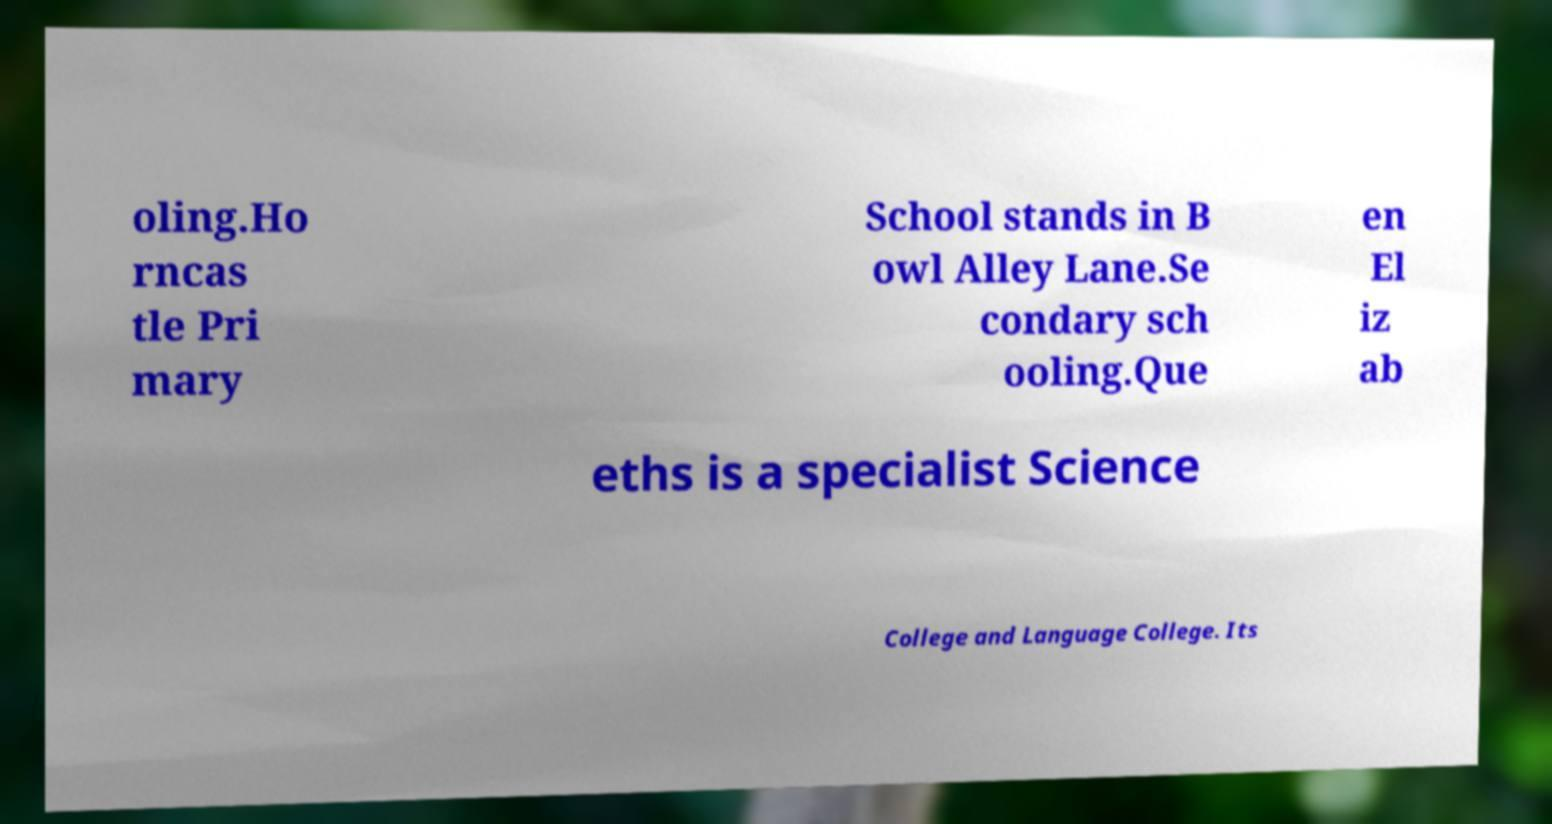There's text embedded in this image that I need extracted. Can you transcribe it verbatim? oling.Ho rncas tle Pri mary School stands in B owl Alley Lane.Se condary sch ooling.Que en El iz ab eths is a specialist Science College and Language College. Its 